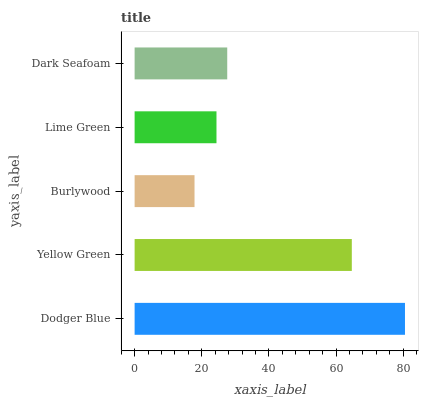Is Burlywood the minimum?
Answer yes or no. Yes. Is Dodger Blue the maximum?
Answer yes or no. Yes. Is Yellow Green the minimum?
Answer yes or no. No. Is Yellow Green the maximum?
Answer yes or no. No. Is Dodger Blue greater than Yellow Green?
Answer yes or no. Yes. Is Yellow Green less than Dodger Blue?
Answer yes or no. Yes. Is Yellow Green greater than Dodger Blue?
Answer yes or no. No. Is Dodger Blue less than Yellow Green?
Answer yes or no. No. Is Dark Seafoam the high median?
Answer yes or no. Yes. Is Dark Seafoam the low median?
Answer yes or no. Yes. Is Lime Green the high median?
Answer yes or no. No. Is Lime Green the low median?
Answer yes or no. No. 